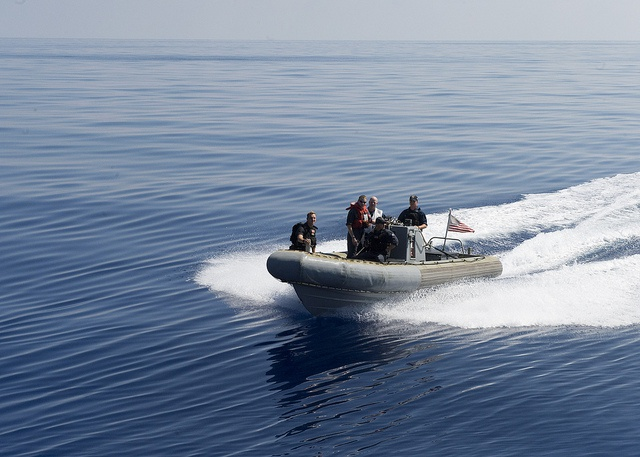Describe the objects in this image and their specific colors. I can see boat in darkgray, black, and gray tones, people in darkgray, black, gray, and maroon tones, people in darkgray, black, and gray tones, people in darkgray, black, gray, and maroon tones, and people in darkgray, black, and gray tones in this image. 